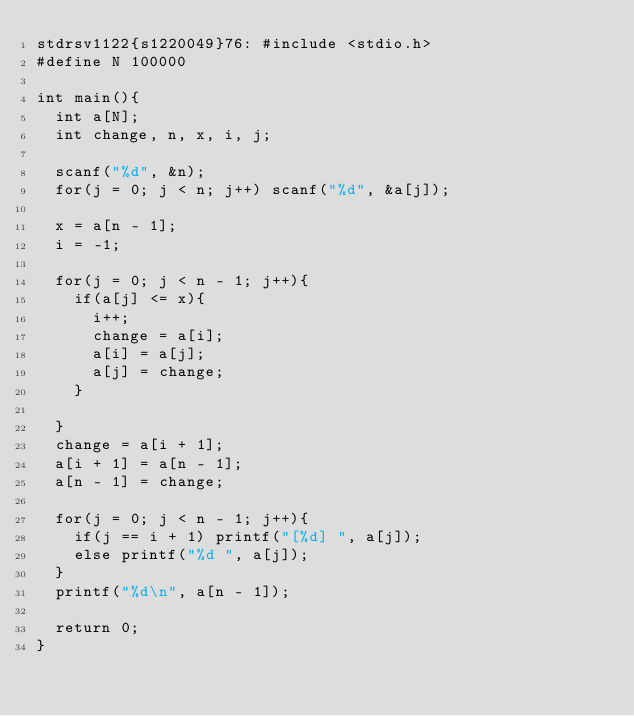Convert code to text. <code><loc_0><loc_0><loc_500><loc_500><_C_>stdrsv1122{s1220049}76:	#include <stdio.h>
#define N 100000

int main(){
  int a[N];
  int change, n, x, i, j;

  scanf("%d", &n);
  for(j = 0; j < n; j++) scanf("%d", &a[j]);

  x = a[n - 1];
  i = -1;

  for(j = 0; j < n - 1; j++){
    if(a[j] <= x){
      i++;
      change = a[i];
      a[i] = a[j];
      a[j] = change;
    }

  }
  change = a[i + 1];
  a[i + 1] = a[n - 1];
  a[n - 1] = change;

  for(j = 0; j < n - 1; j++){
    if(j == i + 1) printf("[%d] ", a[j]);
    else printf("%d ", a[j]);
  }
  printf("%d\n", a[n - 1]);

  return 0;
}</code> 